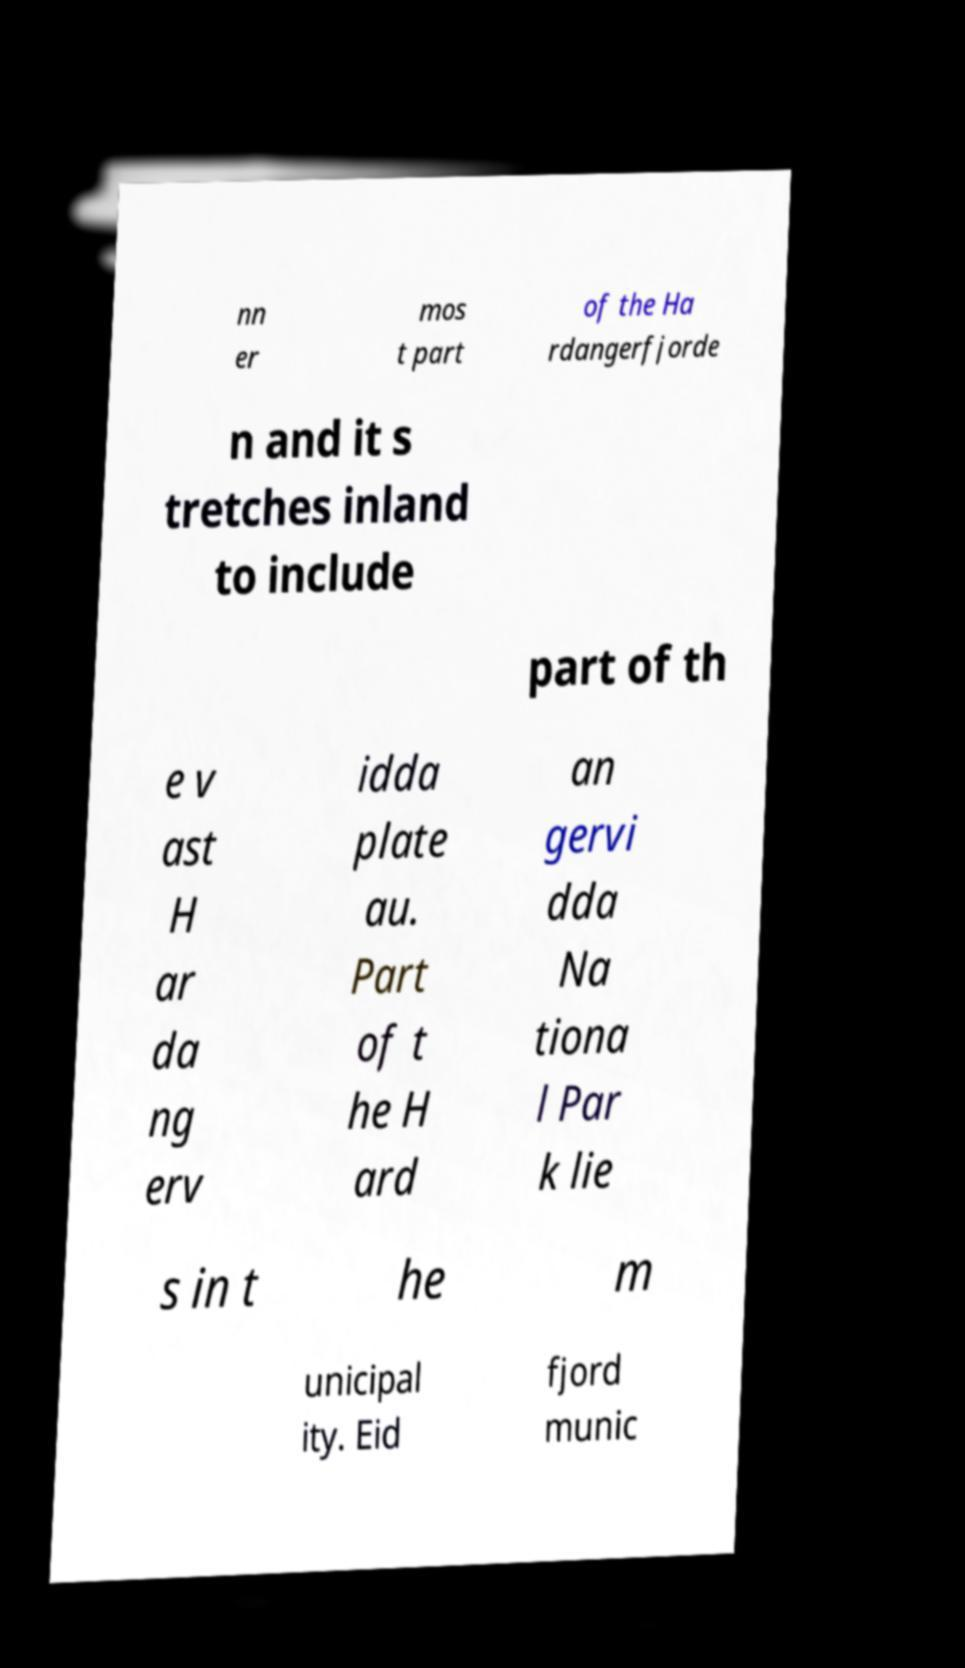Could you assist in decoding the text presented in this image and type it out clearly? nn er mos t part of the Ha rdangerfjorde n and it s tretches inland to include part of th e v ast H ar da ng erv idda plate au. Part of t he H ard an gervi dda Na tiona l Par k lie s in t he m unicipal ity. Eid fjord munic 